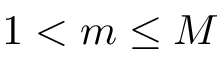<formula> <loc_0><loc_0><loc_500><loc_500>1 < m \leq M</formula> 